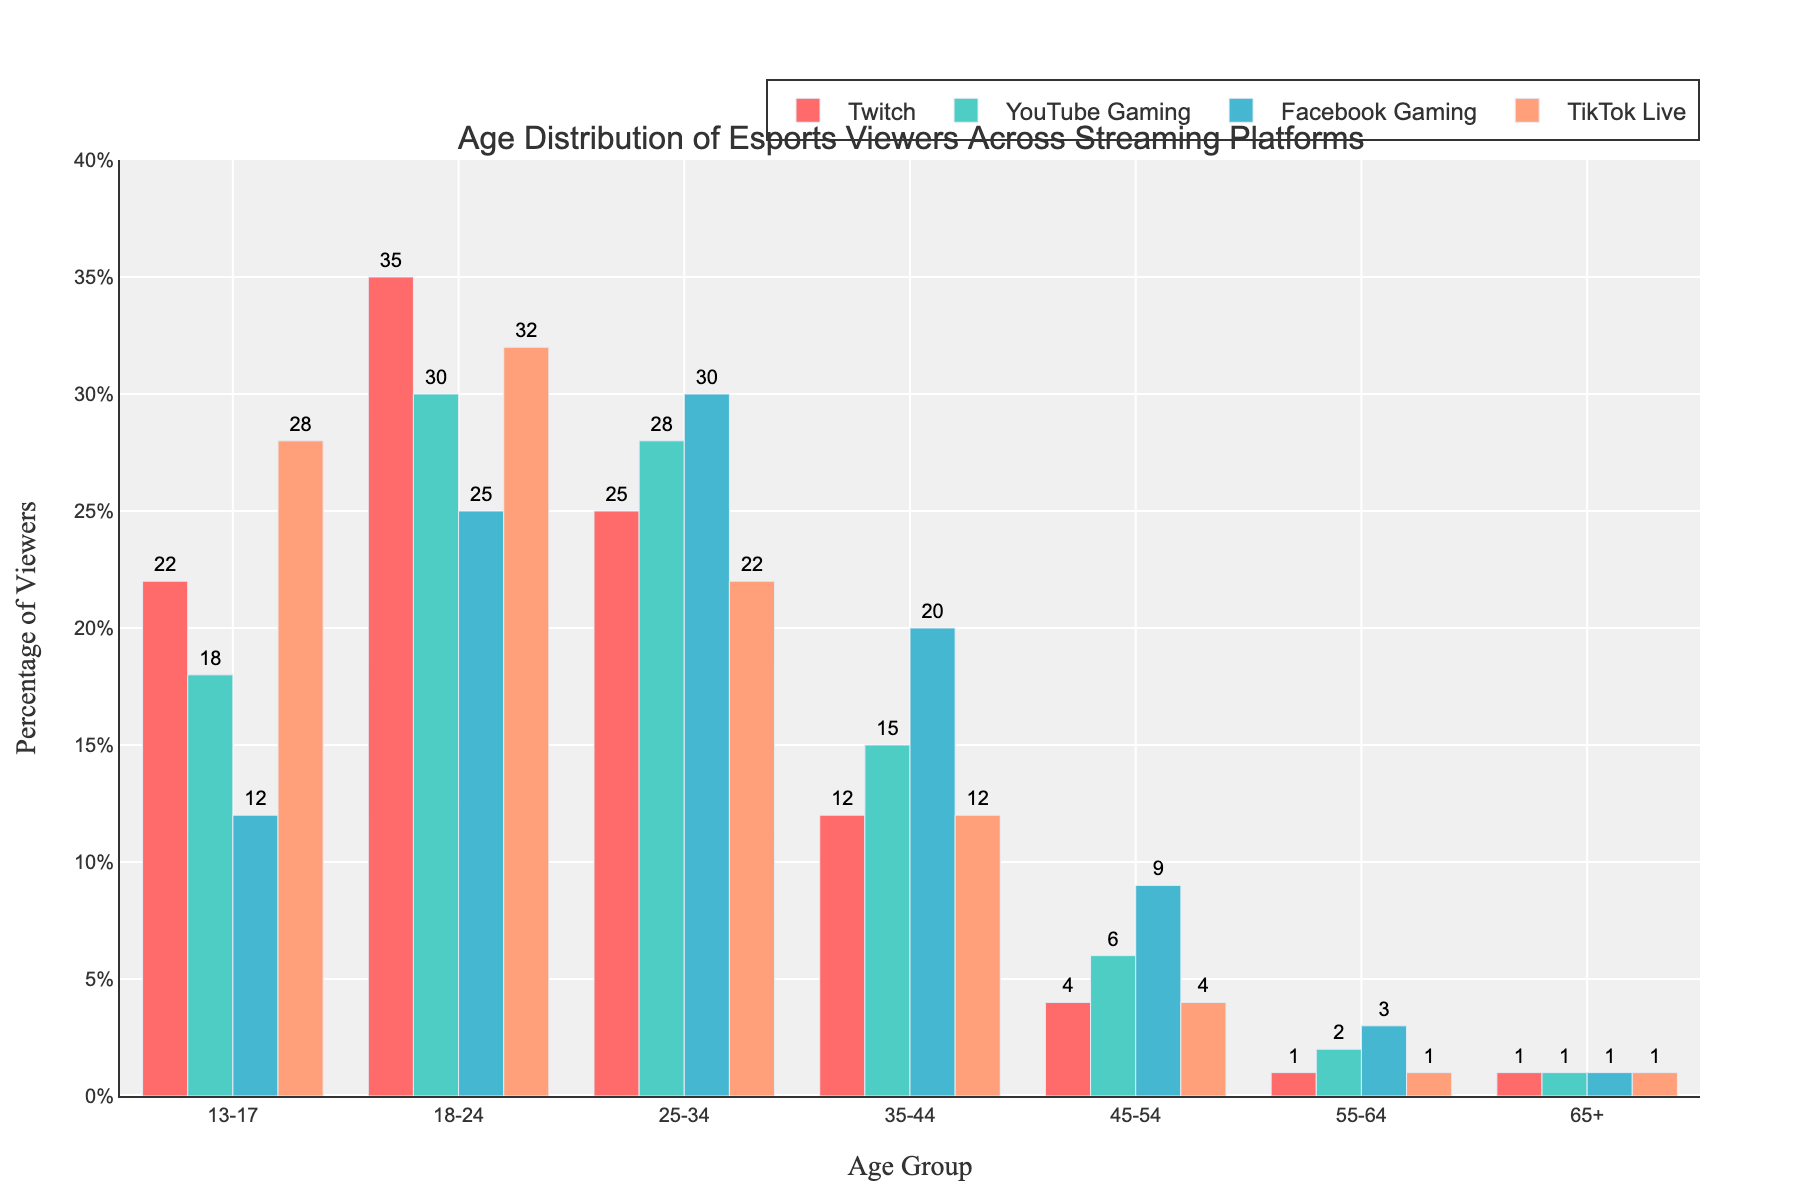Which age group has the highest percentage of viewers on Twitch? The bar representing the age group 18-24 on Twitch is the tallest, indicating the highest percentage.
Answer: 18-24 Which platform has the lowest percentage of viewers aged 55-64? All platforms have a bar representing the age group 55-64; however, Twitch and TikTok Live have the shortest bars for this age group, both at 1%.
Answer: Twitch and TikTok Live How does the percentage of viewers aged 35-44 on Facebook Gaming compare to YouTube Gaming? The bars for the age group 35-44 show that Facebook Gaming has a slightly taller bar than YouTube Gaming, indicating a higher percentage.
Answer: Facebook Gaming Which platform has the widest range (difference between maximum and minimum) of percentage viewer values across all age groups? To determine this, check the highest and lowest values for each platform: 
- Twitch: max is 35% (18-24), min is 1% (55-64, 65+), range = 34%
- YouTube Gaming: max is 30% (18-24), min is 1% (65+), range = 29%
- Facebook Gaming: max is 30% (25-34), min is 1% (65+), range = 29%
- TikTok Live: max is 32% (18-24), min is 1% (55-64, 65+), range = 31%
Twitch has the largest range of 34%.
Answer: Twitch What is the total percentage of viewers aged 18-24 across all platforms? To find this, add the percentages for the age group 18-24:
- Twitch: 35%
- YouTube Gaming: 30%
- Facebook Gaming: 25%
- TikTok Live: 32%
Total is 35 + 30 + 25 + 32 = 122%.
Answer: 122% Which platform has the most even distribution of viewers across all age groups? For even distribution, the percentages should be more consistent across age groups. By looking at the spread of bar heights:
- Twitch: shows significant variation (22%, 35%, 25%, 12%, 4%, 1%, 1%)
- YouTube Gaming: somewhat consistent but not the most (18%, 30%, 28%, 15%, 6%, 2%, 1%)
- Facebook Gaming: more even spread (12%, 25%, 30%, 20%, 9%, 3%, 1%)
- TikTok Live: moderate variation but less consistent (28%, 32%, 22%, 12%, 4%, 1%, 1%)
Facebook Gaming shows the most consistent spread.
Answer: Facebook Gaming Is there a significant drop in viewership from one age group to the next on any platform? Comparing adjacent age groups across platforms:
- Twitch: Significant drop from 18-24 (35%) to 25-34 (25%) and 25-34 (25%) to 35-44 (12%)
- YouTube Gaming: Gradual decreases, no significant drop
- Facebook Gaming: No significant drop
- TikTok Live: Significant drop from 18-24 (32%) to 25-34 (22%)
The significant drops are on Twitch and TikTok Live.
Answer: Twitch and TikTok Live What is the average percentage of viewers across all age groups for YouTube Gaming? The average is calculated by summing up YouTube Gaming's percentages and dividing by the number of age groups: 
(18 + 30 + 28 + 15 + 6 + 2 + 1) / 7 = 100 / 7 ≈ 14.29%.
Answer: 14.29% 